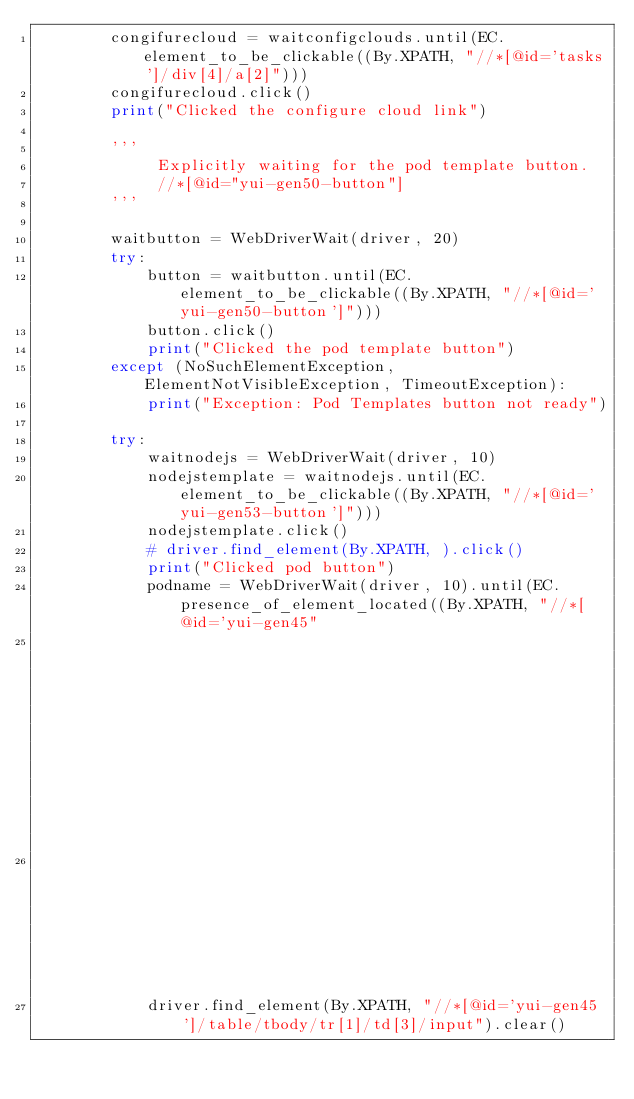Convert code to text. <code><loc_0><loc_0><loc_500><loc_500><_Python_>        congifurecloud = waitconfigclouds.until(EC.element_to_be_clickable((By.XPATH, "//*[@id='tasks']/div[4]/a[2]")))
        congifurecloud.click()
        print("Clicked the configure cloud link")

        '''
             Explicitly waiting for the pod template button.
             //*[@id="yui-gen50-button"]
        '''

        waitbutton = WebDriverWait(driver, 20)
        try:
            button = waitbutton.until(EC.element_to_be_clickable((By.XPATH, "//*[@id='yui-gen50-button']")))
            button.click()
            print("Clicked the pod template button")
        except (NoSuchElementException, ElementNotVisibleException, TimeoutException):
            print("Exception: Pod Templates button not ready")

        try:
            waitnodejs = WebDriverWait(driver, 10)
            nodejstemplate = waitnodejs.until(EC.element_to_be_clickable((By.XPATH, "//*[@id='yui-gen53-button']")))
            nodejstemplate.click()
            # driver.find_element(By.XPATH, ).click()
            print("Clicked pod button")
            podname = WebDriverWait(driver, 10).until(EC.presence_of_element_located((By.XPATH, "//*[@id='yui-gen45"
                                                                                                "']/table/tbody/tr[1]/td["
                                                                                                "3]/input")))
            driver.find_element(By.XPATH, "//*[@id='yui-gen45']/table/tbody/tr[1]/td[3]/input").clear()</code> 